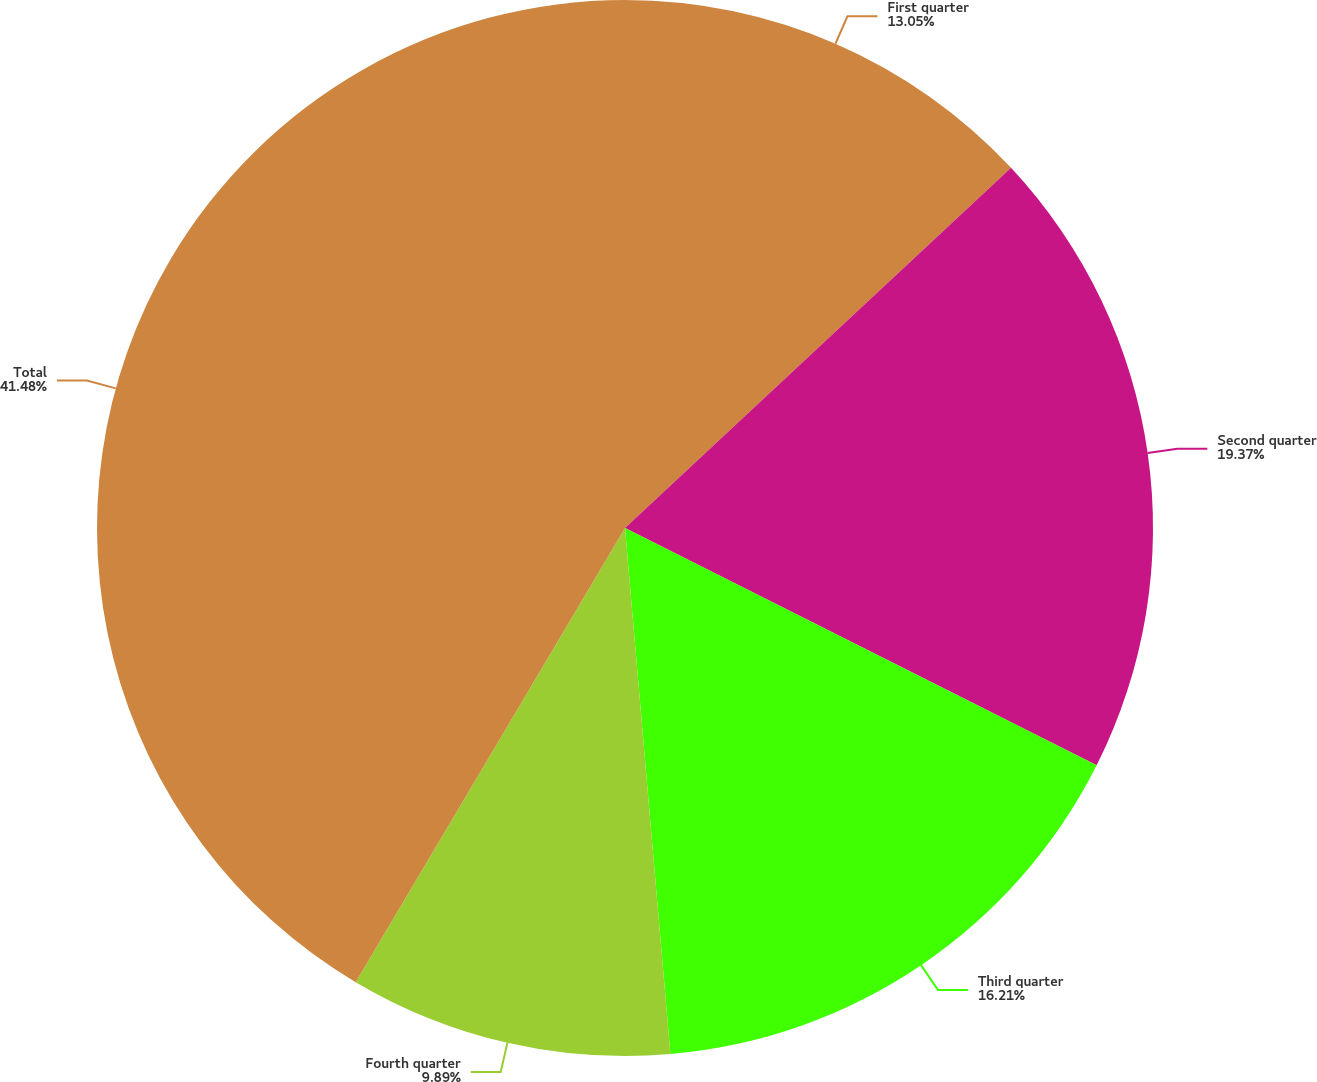Convert chart to OTSL. <chart><loc_0><loc_0><loc_500><loc_500><pie_chart><fcel>First quarter<fcel>Second quarter<fcel>Third quarter<fcel>Fourth quarter<fcel>Total<nl><fcel>13.05%<fcel>19.37%<fcel>16.21%<fcel>9.89%<fcel>41.48%<nl></chart> 